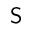Convert formula to latex. <formula><loc_0><loc_0><loc_500><loc_500>S</formula> 